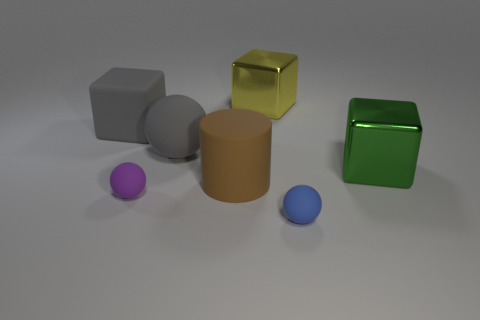Is the material of the brown cylinder the same as the gray block?
Give a very brief answer. Yes. What is the shape of the blue thing?
Provide a short and direct response. Sphere. How many big green metal blocks are on the right side of the tiny rubber thing that is on the left side of the metal block that is left of the blue rubber object?
Offer a very short reply. 1. There is a large object that is the same shape as the small purple object; what is its color?
Ensure brevity in your answer.  Gray. What shape is the tiny thing to the left of the big metal object that is behind the matte sphere behind the cylinder?
Provide a short and direct response. Sphere. How big is the object that is both in front of the large matte cylinder and left of the yellow object?
Provide a short and direct response. Small. Is the number of large blocks less than the number of big objects?
Offer a terse response. Yes. There is a blue rubber sphere that is in front of the big matte cube; what is its size?
Ensure brevity in your answer.  Small. What is the shape of the big thing that is behind the big gray ball and to the left of the matte cylinder?
Your answer should be compact. Cube. What size is the purple thing that is the same shape as the small blue object?
Ensure brevity in your answer.  Small. 